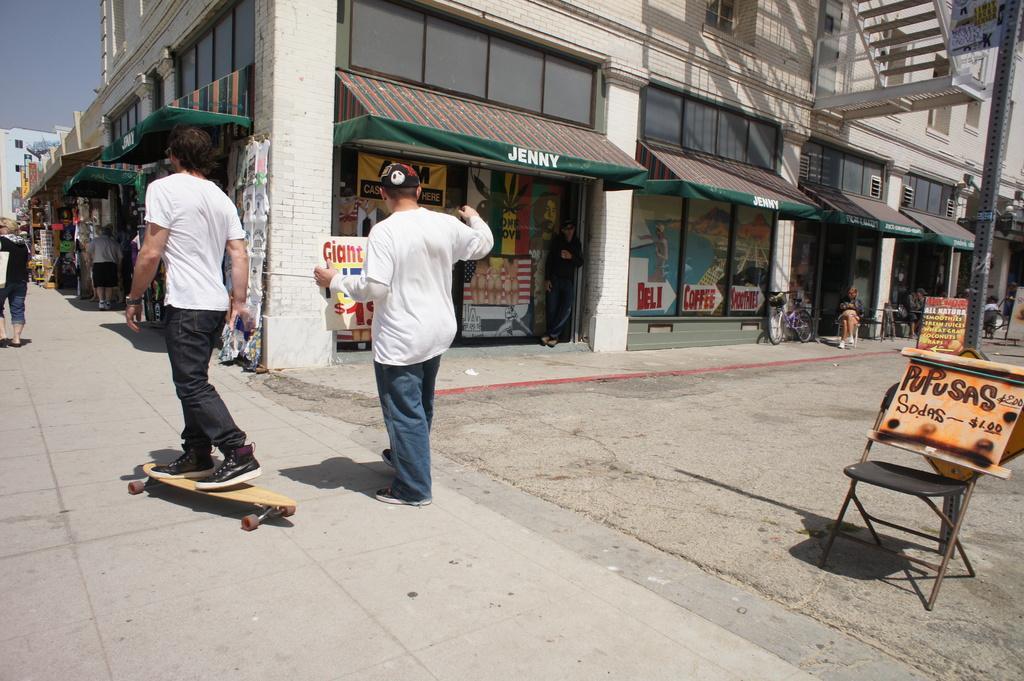Describe this image in one or two sentences. In this picture we can see some people are walking and some people are sitting. A person is skating with the skateboard. On the right side of the people there is a chair, boards, a bicycle and buildings. Behind the buildings there is the sky. 